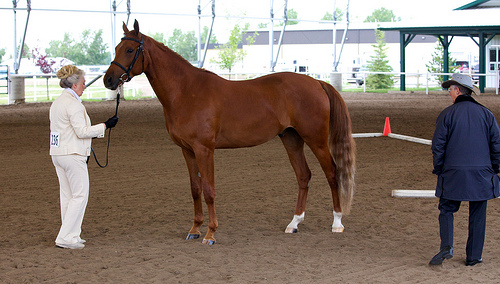<image>
Can you confirm if the women is to the left of the man? No. The women is not to the left of the man. From this viewpoint, they have a different horizontal relationship. 